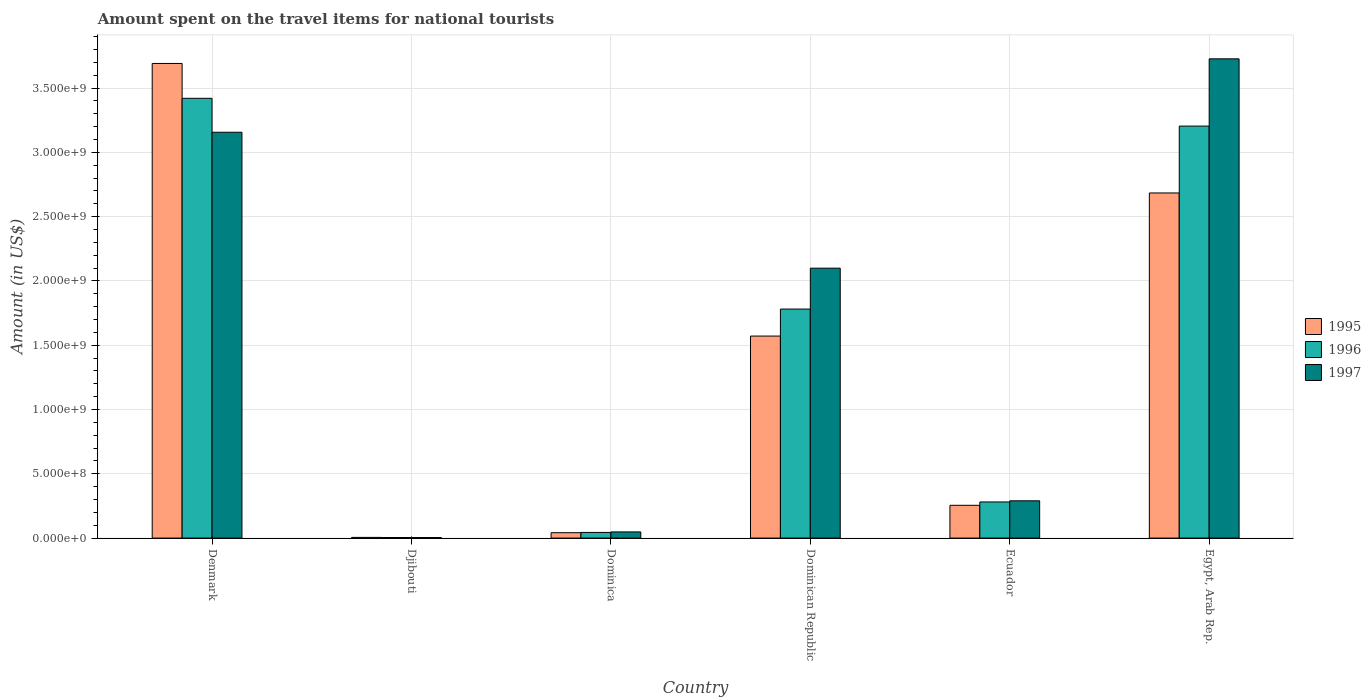How many groups of bars are there?
Make the answer very short. 6. How many bars are there on the 5th tick from the right?
Provide a short and direct response. 3. What is the label of the 6th group of bars from the left?
Keep it short and to the point. Egypt, Arab Rep. What is the amount spent on the travel items for national tourists in 1996 in Egypt, Arab Rep.?
Make the answer very short. 3.20e+09. Across all countries, what is the maximum amount spent on the travel items for national tourists in 1995?
Your answer should be compact. 3.69e+09. Across all countries, what is the minimum amount spent on the travel items for national tourists in 1996?
Give a very brief answer. 4.60e+06. In which country was the amount spent on the travel items for national tourists in 1995 maximum?
Make the answer very short. Denmark. In which country was the amount spent on the travel items for national tourists in 1995 minimum?
Offer a terse response. Djibouti. What is the total amount spent on the travel items for national tourists in 1995 in the graph?
Ensure brevity in your answer.  8.25e+09. What is the difference between the amount spent on the travel items for national tourists in 1996 in Djibouti and that in Dominican Republic?
Make the answer very short. -1.78e+09. What is the difference between the amount spent on the travel items for national tourists in 1995 in Dominican Republic and the amount spent on the travel items for national tourists in 1997 in Egypt, Arab Rep.?
Make the answer very short. -2.16e+09. What is the average amount spent on the travel items for national tourists in 1997 per country?
Provide a short and direct response. 1.55e+09. What is the difference between the amount spent on the travel items for national tourists of/in 1995 and amount spent on the travel items for national tourists of/in 1997 in Denmark?
Ensure brevity in your answer.  5.35e+08. In how many countries, is the amount spent on the travel items for national tourists in 1996 greater than 500000000 US$?
Ensure brevity in your answer.  3. What is the ratio of the amount spent on the travel items for national tourists in 1996 in Dominican Republic to that in Ecuador?
Provide a succinct answer. 6.34. Is the difference between the amount spent on the travel items for national tourists in 1995 in Dominica and Egypt, Arab Rep. greater than the difference between the amount spent on the travel items for national tourists in 1997 in Dominica and Egypt, Arab Rep.?
Your response must be concise. Yes. What is the difference between the highest and the second highest amount spent on the travel items for national tourists in 1995?
Your answer should be compact. 1.01e+09. What is the difference between the highest and the lowest amount spent on the travel items for national tourists in 1996?
Provide a short and direct response. 3.42e+09. In how many countries, is the amount spent on the travel items for national tourists in 1997 greater than the average amount spent on the travel items for national tourists in 1997 taken over all countries?
Provide a short and direct response. 3. Is the sum of the amount spent on the travel items for national tourists in 1995 in Dominica and Ecuador greater than the maximum amount spent on the travel items for national tourists in 1997 across all countries?
Provide a short and direct response. No. What does the 1st bar from the right in Dominica represents?
Your response must be concise. 1997. Is it the case that in every country, the sum of the amount spent on the travel items for national tourists in 1997 and amount spent on the travel items for national tourists in 1996 is greater than the amount spent on the travel items for national tourists in 1995?
Give a very brief answer. Yes. How many bars are there?
Your answer should be very brief. 18. How many countries are there in the graph?
Offer a terse response. 6. Does the graph contain any zero values?
Offer a very short reply. No. What is the title of the graph?
Keep it short and to the point. Amount spent on the travel items for national tourists. What is the label or title of the Y-axis?
Make the answer very short. Amount (in US$). What is the Amount (in US$) of 1995 in Denmark?
Offer a terse response. 3.69e+09. What is the Amount (in US$) of 1996 in Denmark?
Your answer should be very brief. 3.42e+09. What is the Amount (in US$) of 1997 in Denmark?
Your response must be concise. 3.16e+09. What is the Amount (in US$) of 1995 in Djibouti?
Your response must be concise. 5.40e+06. What is the Amount (in US$) in 1996 in Djibouti?
Ensure brevity in your answer.  4.60e+06. What is the Amount (in US$) of 1997 in Djibouti?
Provide a short and direct response. 4.20e+06. What is the Amount (in US$) of 1995 in Dominica?
Provide a succinct answer. 4.20e+07. What is the Amount (in US$) in 1996 in Dominica?
Offer a very short reply. 4.40e+07. What is the Amount (in US$) in 1997 in Dominica?
Offer a very short reply. 4.80e+07. What is the Amount (in US$) in 1995 in Dominican Republic?
Provide a short and direct response. 1.57e+09. What is the Amount (in US$) of 1996 in Dominican Republic?
Provide a succinct answer. 1.78e+09. What is the Amount (in US$) in 1997 in Dominican Republic?
Keep it short and to the point. 2.10e+09. What is the Amount (in US$) in 1995 in Ecuador?
Your answer should be compact. 2.55e+08. What is the Amount (in US$) in 1996 in Ecuador?
Keep it short and to the point. 2.81e+08. What is the Amount (in US$) of 1997 in Ecuador?
Make the answer very short. 2.90e+08. What is the Amount (in US$) in 1995 in Egypt, Arab Rep.?
Make the answer very short. 2.68e+09. What is the Amount (in US$) in 1996 in Egypt, Arab Rep.?
Provide a short and direct response. 3.20e+09. What is the Amount (in US$) of 1997 in Egypt, Arab Rep.?
Your answer should be very brief. 3.73e+09. Across all countries, what is the maximum Amount (in US$) in 1995?
Provide a succinct answer. 3.69e+09. Across all countries, what is the maximum Amount (in US$) of 1996?
Ensure brevity in your answer.  3.42e+09. Across all countries, what is the maximum Amount (in US$) of 1997?
Your response must be concise. 3.73e+09. Across all countries, what is the minimum Amount (in US$) in 1995?
Ensure brevity in your answer.  5.40e+06. Across all countries, what is the minimum Amount (in US$) of 1996?
Make the answer very short. 4.60e+06. Across all countries, what is the minimum Amount (in US$) of 1997?
Offer a very short reply. 4.20e+06. What is the total Amount (in US$) in 1995 in the graph?
Offer a very short reply. 8.25e+09. What is the total Amount (in US$) in 1996 in the graph?
Provide a succinct answer. 8.73e+09. What is the total Amount (in US$) in 1997 in the graph?
Provide a short and direct response. 9.32e+09. What is the difference between the Amount (in US$) in 1995 in Denmark and that in Djibouti?
Your answer should be very brief. 3.69e+09. What is the difference between the Amount (in US$) in 1996 in Denmark and that in Djibouti?
Keep it short and to the point. 3.42e+09. What is the difference between the Amount (in US$) in 1997 in Denmark and that in Djibouti?
Give a very brief answer. 3.15e+09. What is the difference between the Amount (in US$) in 1995 in Denmark and that in Dominica?
Keep it short and to the point. 3.65e+09. What is the difference between the Amount (in US$) in 1996 in Denmark and that in Dominica?
Your response must be concise. 3.38e+09. What is the difference between the Amount (in US$) in 1997 in Denmark and that in Dominica?
Keep it short and to the point. 3.11e+09. What is the difference between the Amount (in US$) of 1995 in Denmark and that in Dominican Republic?
Offer a terse response. 2.12e+09. What is the difference between the Amount (in US$) in 1996 in Denmark and that in Dominican Republic?
Make the answer very short. 1.64e+09. What is the difference between the Amount (in US$) of 1997 in Denmark and that in Dominican Republic?
Make the answer very short. 1.06e+09. What is the difference between the Amount (in US$) of 1995 in Denmark and that in Ecuador?
Make the answer very short. 3.44e+09. What is the difference between the Amount (in US$) of 1996 in Denmark and that in Ecuador?
Make the answer very short. 3.14e+09. What is the difference between the Amount (in US$) in 1997 in Denmark and that in Ecuador?
Ensure brevity in your answer.  2.87e+09. What is the difference between the Amount (in US$) in 1995 in Denmark and that in Egypt, Arab Rep.?
Your answer should be very brief. 1.01e+09. What is the difference between the Amount (in US$) of 1996 in Denmark and that in Egypt, Arab Rep.?
Your answer should be very brief. 2.16e+08. What is the difference between the Amount (in US$) of 1997 in Denmark and that in Egypt, Arab Rep.?
Your answer should be very brief. -5.71e+08. What is the difference between the Amount (in US$) of 1995 in Djibouti and that in Dominica?
Make the answer very short. -3.66e+07. What is the difference between the Amount (in US$) of 1996 in Djibouti and that in Dominica?
Give a very brief answer. -3.94e+07. What is the difference between the Amount (in US$) of 1997 in Djibouti and that in Dominica?
Offer a very short reply. -4.38e+07. What is the difference between the Amount (in US$) in 1995 in Djibouti and that in Dominican Republic?
Give a very brief answer. -1.57e+09. What is the difference between the Amount (in US$) of 1996 in Djibouti and that in Dominican Republic?
Your response must be concise. -1.78e+09. What is the difference between the Amount (in US$) in 1997 in Djibouti and that in Dominican Republic?
Offer a very short reply. -2.09e+09. What is the difference between the Amount (in US$) of 1995 in Djibouti and that in Ecuador?
Give a very brief answer. -2.50e+08. What is the difference between the Amount (in US$) of 1996 in Djibouti and that in Ecuador?
Give a very brief answer. -2.76e+08. What is the difference between the Amount (in US$) in 1997 in Djibouti and that in Ecuador?
Offer a very short reply. -2.86e+08. What is the difference between the Amount (in US$) in 1995 in Djibouti and that in Egypt, Arab Rep.?
Offer a terse response. -2.68e+09. What is the difference between the Amount (in US$) in 1996 in Djibouti and that in Egypt, Arab Rep.?
Provide a succinct answer. -3.20e+09. What is the difference between the Amount (in US$) of 1997 in Djibouti and that in Egypt, Arab Rep.?
Your answer should be compact. -3.72e+09. What is the difference between the Amount (in US$) in 1995 in Dominica and that in Dominican Republic?
Provide a succinct answer. -1.53e+09. What is the difference between the Amount (in US$) of 1996 in Dominica and that in Dominican Republic?
Make the answer very short. -1.74e+09. What is the difference between the Amount (in US$) of 1997 in Dominica and that in Dominican Republic?
Your answer should be very brief. -2.05e+09. What is the difference between the Amount (in US$) in 1995 in Dominica and that in Ecuador?
Give a very brief answer. -2.13e+08. What is the difference between the Amount (in US$) of 1996 in Dominica and that in Ecuador?
Give a very brief answer. -2.37e+08. What is the difference between the Amount (in US$) of 1997 in Dominica and that in Ecuador?
Your answer should be very brief. -2.42e+08. What is the difference between the Amount (in US$) of 1995 in Dominica and that in Egypt, Arab Rep.?
Your answer should be very brief. -2.64e+09. What is the difference between the Amount (in US$) of 1996 in Dominica and that in Egypt, Arab Rep.?
Keep it short and to the point. -3.16e+09. What is the difference between the Amount (in US$) of 1997 in Dominica and that in Egypt, Arab Rep.?
Provide a succinct answer. -3.68e+09. What is the difference between the Amount (in US$) of 1995 in Dominican Republic and that in Ecuador?
Your response must be concise. 1.32e+09. What is the difference between the Amount (in US$) of 1996 in Dominican Republic and that in Ecuador?
Ensure brevity in your answer.  1.50e+09. What is the difference between the Amount (in US$) in 1997 in Dominican Republic and that in Ecuador?
Ensure brevity in your answer.  1.81e+09. What is the difference between the Amount (in US$) in 1995 in Dominican Republic and that in Egypt, Arab Rep.?
Your answer should be compact. -1.11e+09. What is the difference between the Amount (in US$) of 1996 in Dominican Republic and that in Egypt, Arab Rep.?
Your answer should be compact. -1.42e+09. What is the difference between the Amount (in US$) in 1997 in Dominican Republic and that in Egypt, Arab Rep.?
Your answer should be very brief. -1.63e+09. What is the difference between the Amount (in US$) of 1995 in Ecuador and that in Egypt, Arab Rep.?
Make the answer very short. -2.43e+09. What is the difference between the Amount (in US$) of 1996 in Ecuador and that in Egypt, Arab Rep.?
Your answer should be compact. -2.92e+09. What is the difference between the Amount (in US$) of 1997 in Ecuador and that in Egypt, Arab Rep.?
Your answer should be compact. -3.44e+09. What is the difference between the Amount (in US$) in 1995 in Denmark and the Amount (in US$) in 1996 in Djibouti?
Give a very brief answer. 3.69e+09. What is the difference between the Amount (in US$) in 1995 in Denmark and the Amount (in US$) in 1997 in Djibouti?
Your answer should be compact. 3.69e+09. What is the difference between the Amount (in US$) in 1996 in Denmark and the Amount (in US$) in 1997 in Djibouti?
Offer a terse response. 3.42e+09. What is the difference between the Amount (in US$) in 1995 in Denmark and the Amount (in US$) in 1996 in Dominica?
Provide a succinct answer. 3.65e+09. What is the difference between the Amount (in US$) of 1995 in Denmark and the Amount (in US$) of 1997 in Dominica?
Your response must be concise. 3.64e+09. What is the difference between the Amount (in US$) of 1996 in Denmark and the Amount (in US$) of 1997 in Dominica?
Provide a short and direct response. 3.37e+09. What is the difference between the Amount (in US$) of 1995 in Denmark and the Amount (in US$) of 1996 in Dominican Republic?
Make the answer very short. 1.91e+09. What is the difference between the Amount (in US$) in 1995 in Denmark and the Amount (in US$) in 1997 in Dominican Republic?
Your response must be concise. 1.59e+09. What is the difference between the Amount (in US$) of 1996 in Denmark and the Amount (in US$) of 1997 in Dominican Republic?
Provide a succinct answer. 1.32e+09. What is the difference between the Amount (in US$) of 1995 in Denmark and the Amount (in US$) of 1996 in Ecuador?
Provide a succinct answer. 3.41e+09. What is the difference between the Amount (in US$) of 1995 in Denmark and the Amount (in US$) of 1997 in Ecuador?
Give a very brief answer. 3.40e+09. What is the difference between the Amount (in US$) of 1996 in Denmark and the Amount (in US$) of 1997 in Ecuador?
Make the answer very short. 3.13e+09. What is the difference between the Amount (in US$) of 1995 in Denmark and the Amount (in US$) of 1996 in Egypt, Arab Rep.?
Ensure brevity in your answer.  4.87e+08. What is the difference between the Amount (in US$) in 1995 in Denmark and the Amount (in US$) in 1997 in Egypt, Arab Rep.?
Offer a terse response. -3.60e+07. What is the difference between the Amount (in US$) of 1996 in Denmark and the Amount (in US$) of 1997 in Egypt, Arab Rep.?
Provide a succinct answer. -3.07e+08. What is the difference between the Amount (in US$) in 1995 in Djibouti and the Amount (in US$) in 1996 in Dominica?
Offer a very short reply. -3.86e+07. What is the difference between the Amount (in US$) in 1995 in Djibouti and the Amount (in US$) in 1997 in Dominica?
Make the answer very short. -4.26e+07. What is the difference between the Amount (in US$) of 1996 in Djibouti and the Amount (in US$) of 1997 in Dominica?
Offer a very short reply. -4.34e+07. What is the difference between the Amount (in US$) of 1995 in Djibouti and the Amount (in US$) of 1996 in Dominican Republic?
Make the answer very short. -1.78e+09. What is the difference between the Amount (in US$) in 1995 in Djibouti and the Amount (in US$) in 1997 in Dominican Republic?
Keep it short and to the point. -2.09e+09. What is the difference between the Amount (in US$) in 1996 in Djibouti and the Amount (in US$) in 1997 in Dominican Republic?
Give a very brief answer. -2.09e+09. What is the difference between the Amount (in US$) in 1995 in Djibouti and the Amount (in US$) in 1996 in Ecuador?
Make the answer very short. -2.76e+08. What is the difference between the Amount (in US$) of 1995 in Djibouti and the Amount (in US$) of 1997 in Ecuador?
Provide a succinct answer. -2.85e+08. What is the difference between the Amount (in US$) of 1996 in Djibouti and the Amount (in US$) of 1997 in Ecuador?
Offer a very short reply. -2.85e+08. What is the difference between the Amount (in US$) in 1995 in Djibouti and the Amount (in US$) in 1996 in Egypt, Arab Rep.?
Give a very brief answer. -3.20e+09. What is the difference between the Amount (in US$) in 1995 in Djibouti and the Amount (in US$) in 1997 in Egypt, Arab Rep.?
Ensure brevity in your answer.  -3.72e+09. What is the difference between the Amount (in US$) of 1996 in Djibouti and the Amount (in US$) of 1997 in Egypt, Arab Rep.?
Your answer should be very brief. -3.72e+09. What is the difference between the Amount (in US$) of 1995 in Dominica and the Amount (in US$) of 1996 in Dominican Republic?
Your answer should be compact. -1.74e+09. What is the difference between the Amount (in US$) of 1995 in Dominica and the Amount (in US$) of 1997 in Dominican Republic?
Give a very brief answer. -2.06e+09. What is the difference between the Amount (in US$) of 1996 in Dominica and the Amount (in US$) of 1997 in Dominican Republic?
Offer a very short reply. -2.06e+09. What is the difference between the Amount (in US$) in 1995 in Dominica and the Amount (in US$) in 1996 in Ecuador?
Provide a short and direct response. -2.39e+08. What is the difference between the Amount (in US$) of 1995 in Dominica and the Amount (in US$) of 1997 in Ecuador?
Offer a very short reply. -2.48e+08. What is the difference between the Amount (in US$) in 1996 in Dominica and the Amount (in US$) in 1997 in Ecuador?
Ensure brevity in your answer.  -2.46e+08. What is the difference between the Amount (in US$) in 1995 in Dominica and the Amount (in US$) in 1996 in Egypt, Arab Rep.?
Offer a very short reply. -3.16e+09. What is the difference between the Amount (in US$) of 1995 in Dominica and the Amount (in US$) of 1997 in Egypt, Arab Rep.?
Offer a terse response. -3.68e+09. What is the difference between the Amount (in US$) in 1996 in Dominica and the Amount (in US$) in 1997 in Egypt, Arab Rep.?
Ensure brevity in your answer.  -3.68e+09. What is the difference between the Amount (in US$) of 1995 in Dominican Republic and the Amount (in US$) of 1996 in Ecuador?
Your response must be concise. 1.29e+09. What is the difference between the Amount (in US$) in 1995 in Dominican Republic and the Amount (in US$) in 1997 in Ecuador?
Provide a succinct answer. 1.28e+09. What is the difference between the Amount (in US$) in 1996 in Dominican Republic and the Amount (in US$) in 1997 in Ecuador?
Your response must be concise. 1.49e+09. What is the difference between the Amount (in US$) of 1995 in Dominican Republic and the Amount (in US$) of 1996 in Egypt, Arab Rep.?
Offer a very short reply. -1.63e+09. What is the difference between the Amount (in US$) of 1995 in Dominican Republic and the Amount (in US$) of 1997 in Egypt, Arab Rep.?
Make the answer very short. -2.16e+09. What is the difference between the Amount (in US$) in 1996 in Dominican Republic and the Amount (in US$) in 1997 in Egypt, Arab Rep.?
Provide a short and direct response. -1.95e+09. What is the difference between the Amount (in US$) in 1995 in Ecuador and the Amount (in US$) in 1996 in Egypt, Arab Rep.?
Your answer should be very brief. -2.95e+09. What is the difference between the Amount (in US$) in 1995 in Ecuador and the Amount (in US$) in 1997 in Egypt, Arab Rep.?
Keep it short and to the point. -3.47e+09. What is the difference between the Amount (in US$) of 1996 in Ecuador and the Amount (in US$) of 1997 in Egypt, Arab Rep.?
Keep it short and to the point. -3.45e+09. What is the average Amount (in US$) in 1995 per country?
Give a very brief answer. 1.37e+09. What is the average Amount (in US$) in 1996 per country?
Ensure brevity in your answer.  1.46e+09. What is the average Amount (in US$) of 1997 per country?
Ensure brevity in your answer.  1.55e+09. What is the difference between the Amount (in US$) in 1995 and Amount (in US$) in 1996 in Denmark?
Offer a terse response. 2.71e+08. What is the difference between the Amount (in US$) of 1995 and Amount (in US$) of 1997 in Denmark?
Provide a succinct answer. 5.35e+08. What is the difference between the Amount (in US$) of 1996 and Amount (in US$) of 1997 in Denmark?
Provide a short and direct response. 2.64e+08. What is the difference between the Amount (in US$) in 1995 and Amount (in US$) in 1997 in Djibouti?
Keep it short and to the point. 1.20e+06. What is the difference between the Amount (in US$) of 1995 and Amount (in US$) of 1996 in Dominica?
Offer a very short reply. -2.00e+06. What is the difference between the Amount (in US$) in 1995 and Amount (in US$) in 1997 in Dominica?
Offer a terse response. -6.00e+06. What is the difference between the Amount (in US$) in 1996 and Amount (in US$) in 1997 in Dominica?
Keep it short and to the point. -4.00e+06. What is the difference between the Amount (in US$) of 1995 and Amount (in US$) of 1996 in Dominican Republic?
Keep it short and to the point. -2.10e+08. What is the difference between the Amount (in US$) in 1995 and Amount (in US$) in 1997 in Dominican Republic?
Ensure brevity in your answer.  -5.28e+08. What is the difference between the Amount (in US$) in 1996 and Amount (in US$) in 1997 in Dominican Republic?
Ensure brevity in your answer.  -3.18e+08. What is the difference between the Amount (in US$) of 1995 and Amount (in US$) of 1996 in Ecuador?
Your answer should be very brief. -2.60e+07. What is the difference between the Amount (in US$) in 1995 and Amount (in US$) in 1997 in Ecuador?
Your answer should be very brief. -3.50e+07. What is the difference between the Amount (in US$) of 1996 and Amount (in US$) of 1997 in Ecuador?
Provide a short and direct response. -9.00e+06. What is the difference between the Amount (in US$) of 1995 and Amount (in US$) of 1996 in Egypt, Arab Rep.?
Your response must be concise. -5.20e+08. What is the difference between the Amount (in US$) of 1995 and Amount (in US$) of 1997 in Egypt, Arab Rep.?
Make the answer very short. -1.04e+09. What is the difference between the Amount (in US$) of 1996 and Amount (in US$) of 1997 in Egypt, Arab Rep.?
Your response must be concise. -5.23e+08. What is the ratio of the Amount (in US$) of 1995 in Denmark to that in Djibouti?
Give a very brief answer. 683.52. What is the ratio of the Amount (in US$) of 1996 in Denmark to that in Djibouti?
Offer a terse response. 743.48. What is the ratio of the Amount (in US$) of 1997 in Denmark to that in Djibouti?
Your answer should be compact. 751.43. What is the ratio of the Amount (in US$) in 1995 in Denmark to that in Dominica?
Ensure brevity in your answer.  87.88. What is the ratio of the Amount (in US$) of 1996 in Denmark to that in Dominica?
Offer a terse response. 77.73. What is the ratio of the Amount (in US$) in 1997 in Denmark to that in Dominica?
Provide a succinct answer. 65.75. What is the ratio of the Amount (in US$) in 1995 in Denmark to that in Dominican Republic?
Give a very brief answer. 2.35. What is the ratio of the Amount (in US$) of 1996 in Denmark to that in Dominican Republic?
Offer a very short reply. 1.92. What is the ratio of the Amount (in US$) of 1997 in Denmark to that in Dominican Republic?
Provide a succinct answer. 1.5. What is the ratio of the Amount (in US$) of 1995 in Denmark to that in Ecuador?
Offer a terse response. 14.47. What is the ratio of the Amount (in US$) in 1996 in Denmark to that in Ecuador?
Ensure brevity in your answer.  12.17. What is the ratio of the Amount (in US$) of 1997 in Denmark to that in Ecuador?
Make the answer very short. 10.88. What is the ratio of the Amount (in US$) in 1995 in Denmark to that in Egypt, Arab Rep.?
Make the answer very short. 1.38. What is the ratio of the Amount (in US$) in 1996 in Denmark to that in Egypt, Arab Rep.?
Give a very brief answer. 1.07. What is the ratio of the Amount (in US$) in 1997 in Denmark to that in Egypt, Arab Rep.?
Keep it short and to the point. 0.85. What is the ratio of the Amount (in US$) in 1995 in Djibouti to that in Dominica?
Offer a very short reply. 0.13. What is the ratio of the Amount (in US$) of 1996 in Djibouti to that in Dominica?
Ensure brevity in your answer.  0.1. What is the ratio of the Amount (in US$) in 1997 in Djibouti to that in Dominica?
Give a very brief answer. 0.09. What is the ratio of the Amount (in US$) in 1995 in Djibouti to that in Dominican Republic?
Your response must be concise. 0. What is the ratio of the Amount (in US$) in 1996 in Djibouti to that in Dominican Republic?
Provide a succinct answer. 0. What is the ratio of the Amount (in US$) in 1997 in Djibouti to that in Dominican Republic?
Your answer should be compact. 0. What is the ratio of the Amount (in US$) of 1995 in Djibouti to that in Ecuador?
Provide a short and direct response. 0.02. What is the ratio of the Amount (in US$) of 1996 in Djibouti to that in Ecuador?
Provide a succinct answer. 0.02. What is the ratio of the Amount (in US$) in 1997 in Djibouti to that in Ecuador?
Offer a very short reply. 0.01. What is the ratio of the Amount (in US$) of 1995 in Djibouti to that in Egypt, Arab Rep.?
Your response must be concise. 0. What is the ratio of the Amount (in US$) of 1996 in Djibouti to that in Egypt, Arab Rep.?
Ensure brevity in your answer.  0. What is the ratio of the Amount (in US$) of 1997 in Djibouti to that in Egypt, Arab Rep.?
Ensure brevity in your answer.  0. What is the ratio of the Amount (in US$) of 1995 in Dominica to that in Dominican Republic?
Provide a succinct answer. 0.03. What is the ratio of the Amount (in US$) of 1996 in Dominica to that in Dominican Republic?
Offer a very short reply. 0.02. What is the ratio of the Amount (in US$) of 1997 in Dominica to that in Dominican Republic?
Offer a very short reply. 0.02. What is the ratio of the Amount (in US$) in 1995 in Dominica to that in Ecuador?
Keep it short and to the point. 0.16. What is the ratio of the Amount (in US$) of 1996 in Dominica to that in Ecuador?
Your response must be concise. 0.16. What is the ratio of the Amount (in US$) of 1997 in Dominica to that in Ecuador?
Give a very brief answer. 0.17. What is the ratio of the Amount (in US$) of 1995 in Dominica to that in Egypt, Arab Rep.?
Make the answer very short. 0.02. What is the ratio of the Amount (in US$) in 1996 in Dominica to that in Egypt, Arab Rep.?
Ensure brevity in your answer.  0.01. What is the ratio of the Amount (in US$) of 1997 in Dominica to that in Egypt, Arab Rep.?
Your answer should be very brief. 0.01. What is the ratio of the Amount (in US$) in 1995 in Dominican Republic to that in Ecuador?
Make the answer very short. 6.16. What is the ratio of the Amount (in US$) in 1996 in Dominican Republic to that in Ecuador?
Keep it short and to the point. 6.34. What is the ratio of the Amount (in US$) of 1997 in Dominican Republic to that in Ecuador?
Make the answer very short. 7.24. What is the ratio of the Amount (in US$) of 1995 in Dominican Republic to that in Egypt, Arab Rep.?
Your response must be concise. 0.59. What is the ratio of the Amount (in US$) of 1996 in Dominican Republic to that in Egypt, Arab Rep.?
Offer a very short reply. 0.56. What is the ratio of the Amount (in US$) of 1997 in Dominican Republic to that in Egypt, Arab Rep.?
Make the answer very short. 0.56. What is the ratio of the Amount (in US$) in 1995 in Ecuador to that in Egypt, Arab Rep.?
Make the answer very short. 0.1. What is the ratio of the Amount (in US$) in 1996 in Ecuador to that in Egypt, Arab Rep.?
Ensure brevity in your answer.  0.09. What is the ratio of the Amount (in US$) in 1997 in Ecuador to that in Egypt, Arab Rep.?
Provide a short and direct response. 0.08. What is the difference between the highest and the second highest Amount (in US$) in 1995?
Make the answer very short. 1.01e+09. What is the difference between the highest and the second highest Amount (in US$) in 1996?
Make the answer very short. 2.16e+08. What is the difference between the highest and the second highest Amount (in US$) of 1997?
Your response must be concise. 5.71e+08. What is the difference between the highest and the lowest Amount (in US$) in 1995?
Give a very brief answer. 3.69e+09. What is the difference between the highest and the lowest Amount (in US$) in 1996?
Give a very brief answer. 3.42e+09. What is the difference between the highest and the lowest Amount (in US$) in 1997?
Provide a succinct answer. 3.72e+09. 